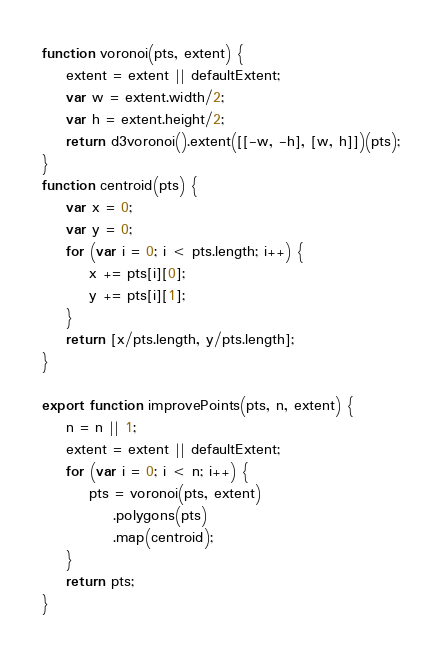<code> <loc_0><loc_0><loc_500><loc_500><_JavaScript_>
function voronoi(pts, extent) {
    extent = extent || defaultExtent;
    var w = extent.width/2;
    var h = extent.height/2;
    return d3voronoi().extent([[-w, -h], [w, h]])(pts);
}
function centroid(pts) {
    var x = 0;
    var y = 0;
    for (var i = 0; i < pts.length; i++) {
        x += pts[i][0];
        y += pts[i][1];
    }
    return [x/pts.length, y/pts.length];
}

export function improvePoints(pts, n, extent) {
    n = n || 1;
    extent = extent || defaultExtent;
    for (var i = 0; i < n; i++) {
        pts = voronoi(pts, extent)
            .polygons(pts)
            .map(centroid);
    }
    return pts;
}
</code> 